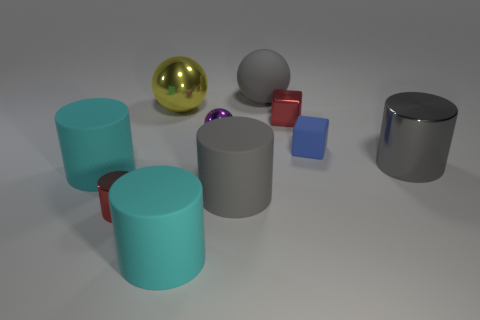Subtract 1 cylinders. How many cylinders are left? 4 Subtract all blue cylinders. Subtract all gray spheres. How many cylinders are left? 5 Subtract all cubes. How many objects are left? 8 Subtract 0 yellow cylinders. How many objects are left? 10 Subtract all large metallic spheres. Subtract all large yellow shiny balls. How many objects are left? 8 Add 2 tiny rubber cubes. How many tiny rubber cubes are left? 3 Add 1 large cyan cylinders. How many large cyan cylinders exist? 3 